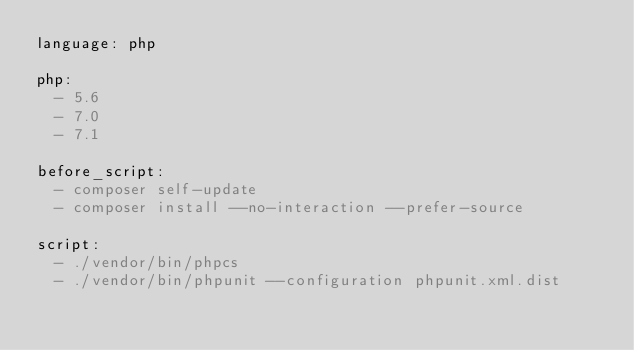Convert code to text. <code><loc_0><loc_0><loc_500><loc_500><_YAML_>language: php

php:
  - 5.6
  - 7.0
  - 7.1

before_script:
  - composer self-update
  - composer install --no-interaction --prefer-source

script:
  - ./vendor/bin/phpcs
  - ./vendor/bin/phpunit --configuration phpunit.xml.dist
</code> 